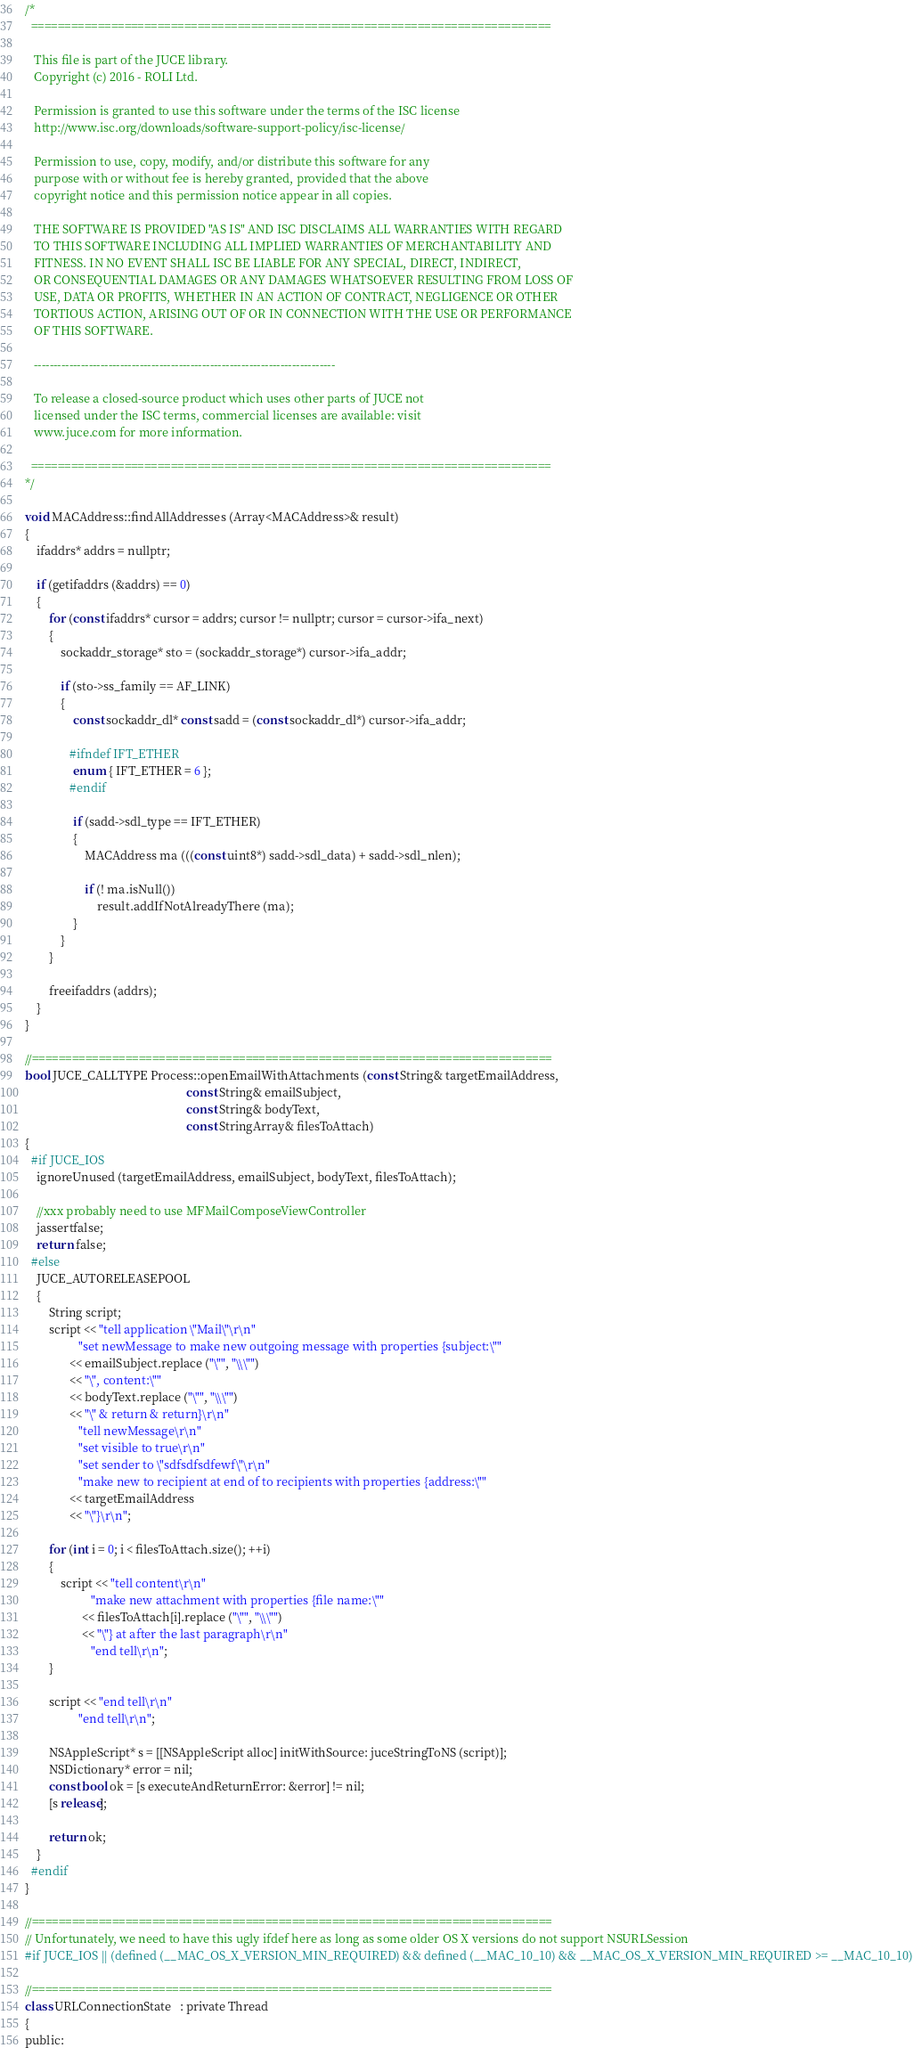Convert code to text. <code><loc_0><loc_0><loc_500><loc_500><_ObjectiveC_>/*
  ==============================================================================

   This file is part of the JUCE library.
   Copyright (c) 2016 - ROLI Ltd.

   Permission is granted to use this software under the terms of the ISC license
   http://www.isc.org/downloads/software-support-policy/isc-license/

   Permission to use, copy, modify, and/or distribute this software for any
   purpose with or without fee is hereby granted, provided that the above
   copyright notice and this permission notice appear in all copies.

   THE SOFTWARE IS PROVIDED "AS IS" AND ISC DISCLAIMS ALL WARRANTIES WITH REGARD
   TO THIS SOFTWARE INCLUDING ALL IMPLIED WARRANTIES OF MERCHANTABILITY AND
   FITNESS. IN NO EVENT SHALL ISC BE LIABLE FOR ANY SPECIAL, DIRECT, INDIRECT,
   OR CONSEQUENTIAL DAMAGES OR ANY DAMAGES WHATSOEVER RESULTING FROM LOSS OF
   USE, DATA OR PROFITS, WHETHER IN AN ACTION OF CONTRACT, NEGLIGENCE OR OTHER
   TORTIOUS ACTION, ARISING OUT OF OR IN CONNECTION WITH THE USE OR PERFORMANCE
   OF THIS SOFTWARE.

   -----------------------------------------------------------------------------

   To release a closed-source product which uses other parts of JUCE not
   licensed under the ISC terms, commercial licenses are available: visit
   www.juce.com for more information.

  ==============================================================================
*/

void MACAddress::findAllAddresses (Array<MACAddress>& result)
{
    ifaddrs* addrs = nullptr;

    if (getifaddrs (&addrs) == 0)
    {
        for (const ifaddrs* cursor = addrs; cursor != nullptr; cursor = cursor->ifa_next)
        {
            sockaddr_storage* sto = (sockaddr_storage*) cursor->ifa_addr;

            if (sto->ss_family == AF_LINK)
            {
                const sockaddr_dl* const sadd = (const sockaddr_dl*) cursor->ifa_addr;

               #ifndef IFT_ETHER
                enum { IFT_ETHER = 6 };
               #endif

                if (sadd->sdl_type == IFT_ETHER)
                {
                    MACAddress ma (((const uint8*) sadd->sdl_data) + sadd->sdl_nlen);

                    if (! ma.isNull())
                        result.addIfNotAlreadyThere (ma);
                }
            }
        }

        freeifaddrs (addrs);
    }
}

//==============================================================================
bool JUCE_CALLTYPE Process::openEmailWithAttachments (const String& targetEmailAddress,
                                                      const String& emailSubject,
                                                      const String& bodyText,
                                                      const StringArray& filesToAttach)
{
  #if JUCE_IOS
    ignoreUnused (targetEmailAddress, emailSubject, bodyText, filesToAttach);

    //xxx probably need to use MFMailComposeViewController
    jassertfalse;
    return false;
  #else
    JUCE_AUTORELEASEPOOL
    {
        String script;
        script << "tell application \"Mail\"\r\n"
                  "set newMessage to make new outgoing message with properties {subject:\""
               << emailSubject.replace ("\"", "\\\"")
               << "\", content:\""
               << bodyText.replace ("\"", "\\\"")
               << "\" & return & return}\r\n"
                  "tell newMessage\r\n"
                  "set visible to true\r\n"
                  "set sender to \"sdfsdfsdfewf\"\r\n"
                  "make new to recipient at end of to recipients with properties {address:\""
               << targetEmailAddress
               << "\"}\r\n";

        for (int i = 0; i < filesToAttach.size(); ++i)
        {
            script << "tell content\r\n"
                      "make new attachment with properties {file name:\""
                   << filesToAttach[i].replace ("\"", "\\\"")
                   << "\"} at after the last paragraph\r\n"
                      "end tell\r\n";
        }

        script << "end tell\r\n"
                  "end tell\r\n";

        NSAppleScript* s = [[NSAppleScript alloc] initWithSource: juceStringToNS (script)];
        NSDictionary* error = nil;
        const bool ok = [s executeAndReturnError: &error] != nil;
        [s release];

        return ok;
    }
  #endif
}

//==============================================================================
// Unfortunately, we need to have this ugly ifdef here as long as some older OS X versions do not support NSURLSession
#if JUCE_IOS || (defined (__MAC_OS_X_VERSION_MIN_REQUIRED) && defined (__MAC_10_10) && __MAC_OS_X_VERSION_MIN_REQUIRED >= __MAC_10_10)

//==============================================================================
class URLConnectionState   : private Thread
{
public:</code> 